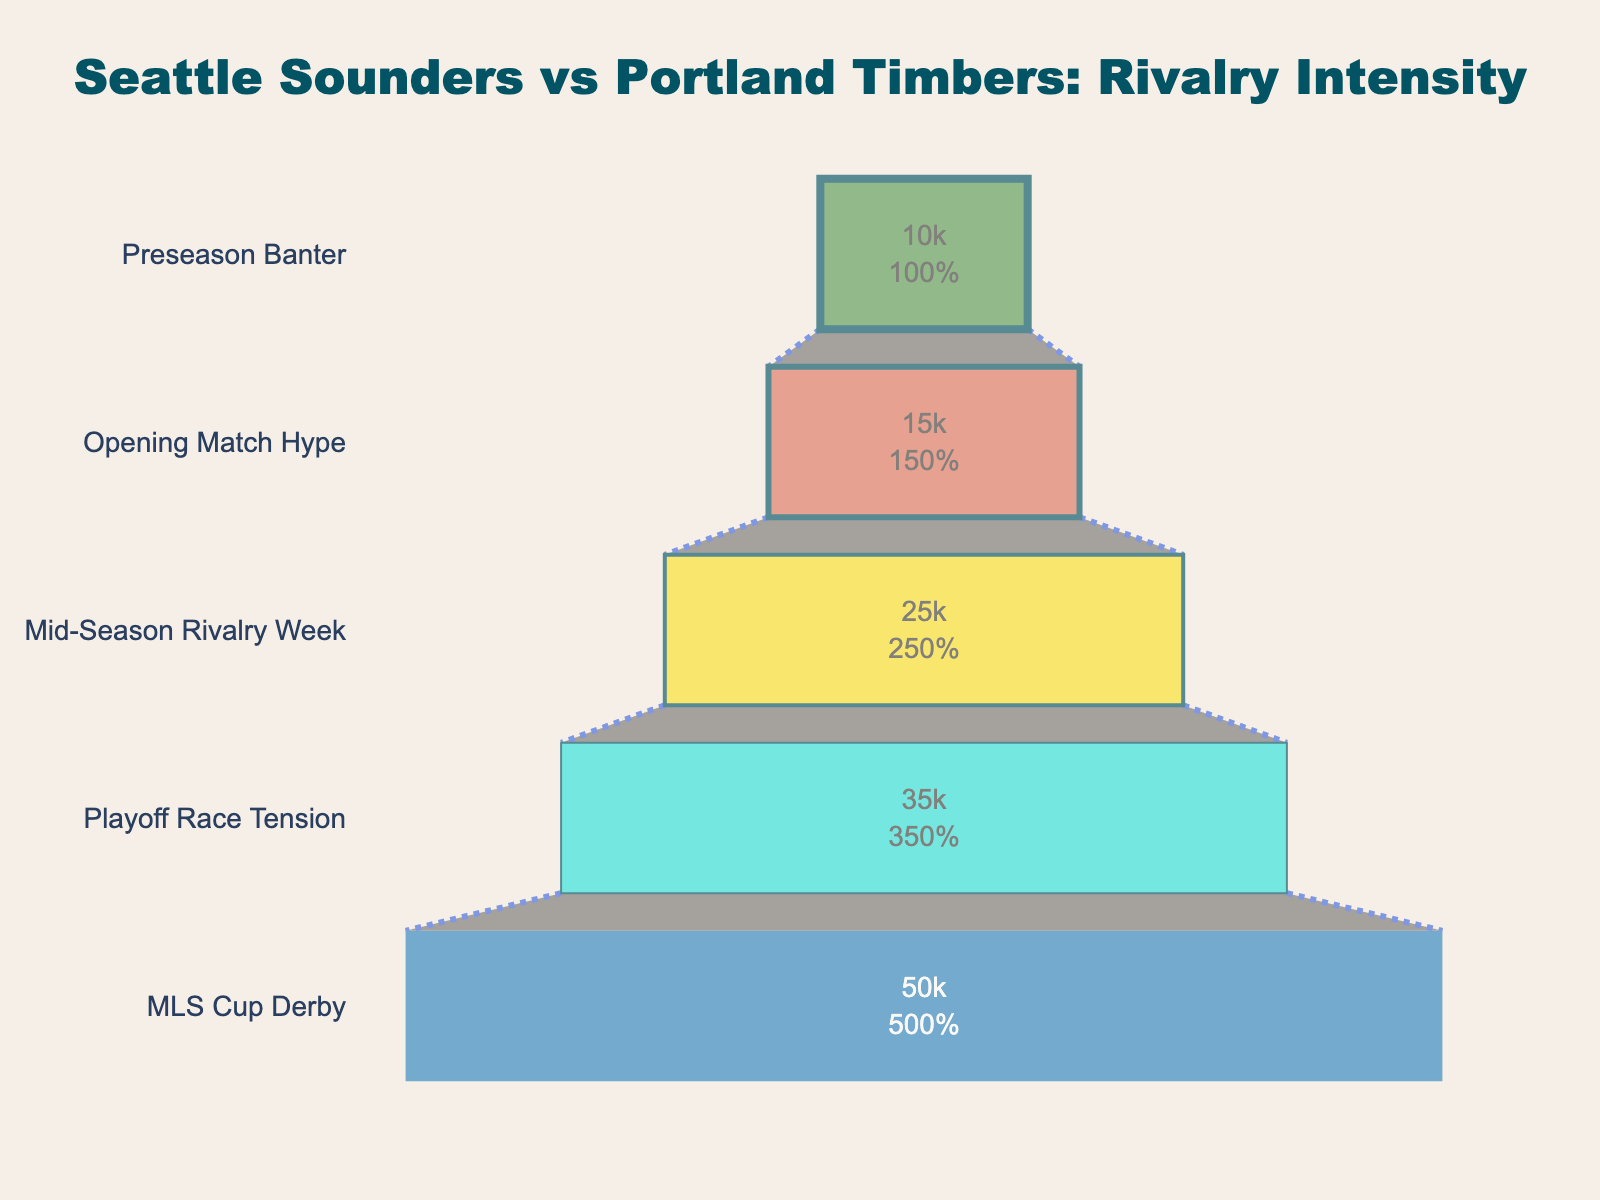What is the title of the funnel chart? The title of a chart is usually displayed at the top and often provides a brief summary of what the chart represents. In this funnel chart, the title is situated at the center-top of the figure.
Answer: Seattle Sounders vs Portland Timbers: Rivalry Intensity How many stages are listed in the funnel chart? By evaluating the funnel's vertical segmentation, it appears there are different stages annotated on the y-axis or funnel partitions. By counting them from top to bottom, we see there are five distinct stages listed.
Answer: Five What is the stage with the highest number of fans engaged? To identify the stage with the highest number of fans, one should look at the x-axis representing fan engagement and see which stage has the highest value. Here, the stage "MLS Cup Derby" has the highest value.
Answer: MLS Cup Derby What color is used for the "Opening Match Hype" stage? Each stage in the funnel is differentiated by a unique color. By locating the "Opening Match Hype," we see it is assigned a specific color among the five colors used.
Answer: It's a shade of red What is the intensity level at "Mid-Season Rivalry Week" stage? The intensity levels are shown in the data next to each stage. By referring to the "Mid-Season Rivalry Week," we see the intensity level associated with it.
Answer: 60 What is the total number of fans engaged across all stages? To find the total, add the number of fans in all five stages: 10,000 (Preseason Banter) + 15,000 (Opening Match Hype) + 25,000 (Mid-Season Rivalry Week) + 35,000 (Playoff Race Tension) + 50,000 (MLS Cup Derby).
Answer: 135,000 How does the fan engagement of "Playoff Race Tension" compare to "Opening Match Hype"? To compare, subtract the number of fans in "Opening Match Hype" from those in "Playoff Race Tension": 35,000 - 15,000.
Answer: 20,000 more fans Which stage shows the smallest increase in fan engagement compared to the previous stage? Calculations are required between consecutive stages: 
1. Opening Match Hype - Preseason Banter: 15,000 - 10,000 = 5,000
2. Mid-Season Rivalry Week - Opening Match Hype: 25,000 - 15,000 = 10,000
3. Playoff Race Tension - Mid-Season Rivalry Week: 35,000 - 25,000 = 10,000
4. MLS Cup Derby - Playoff Race Tension: 50,000 - 35,000 = 15,000
The smallest positive difference is between Preseason Banter and Opening Match Hype.
Answer: 5,000 What is the average number of fans engaged per stage? To calculate, sum the total number of fans engaged and divide by the number of stages: 135,000 Fans / 5 Stages.
Answer: 27,000 Which stage has the lowest intensity level, and what is that level? Observing the intensity levels, the stage with the lowest value is "Preseason Banter."
Answer: Preseason Banter, 20 